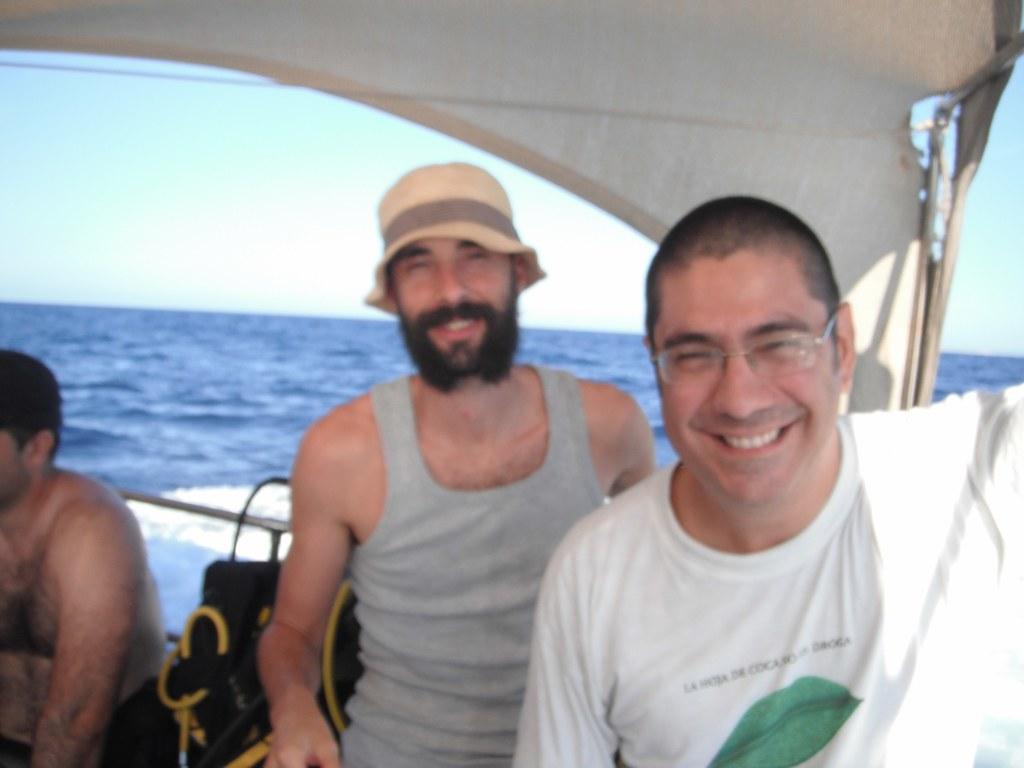Please provide a concise description of this image. In this image we can see a boat on the water, in the boat we can see the persons and some other objects, in the background we can see the sky. 